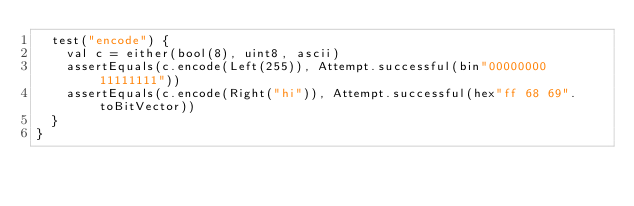<code> <loc_0><loc_0><loc_500><loc_500><_Scala_>  test("encode") {
    val c = either(bool(8), uint8, ascii)
    assertEquals(c.encode(Left(255)), Attempt.successful(bin"00000000 11111111"))
    assertEquals(c.encode(Right("hi")), Attempt.successful(hex"ff 68 69".toBitVector))
  }
}
</code> 